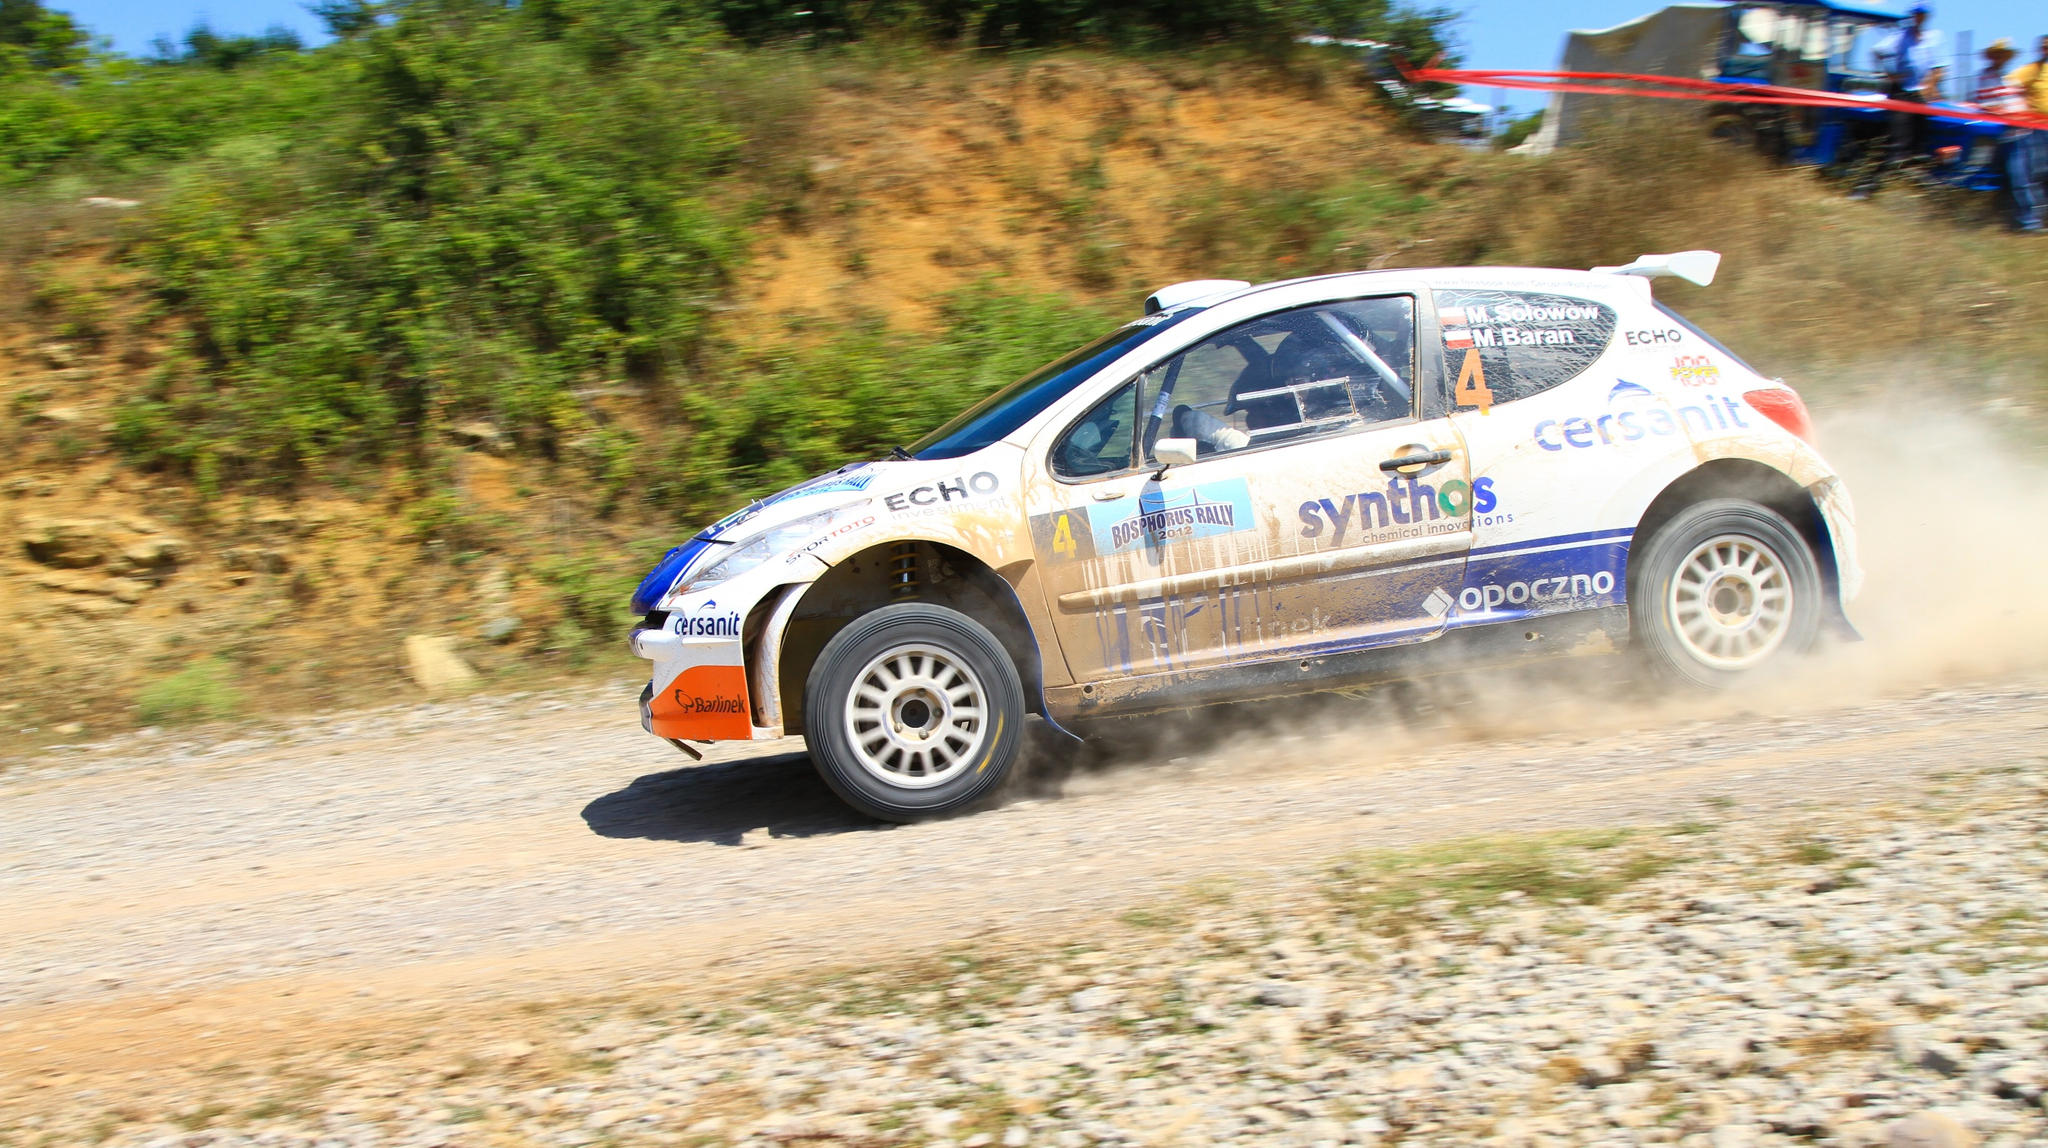What challenges do drivers face when racing in such terrains? Rally drivers tackle a myriad of challenges on such unpaved terrains. These include managing varying surface textures that can abruptly change from dirt to gravel, affecting traction and vehicle control. The unpredictable nature of the road, combined with obstacles like sharp turns and elevation changes, tests both the driver's skill and the car’s durability. Moreover, maintaining high speeds while ensuring the vehicle's stability and navigating safely requires precision and expert timing. 